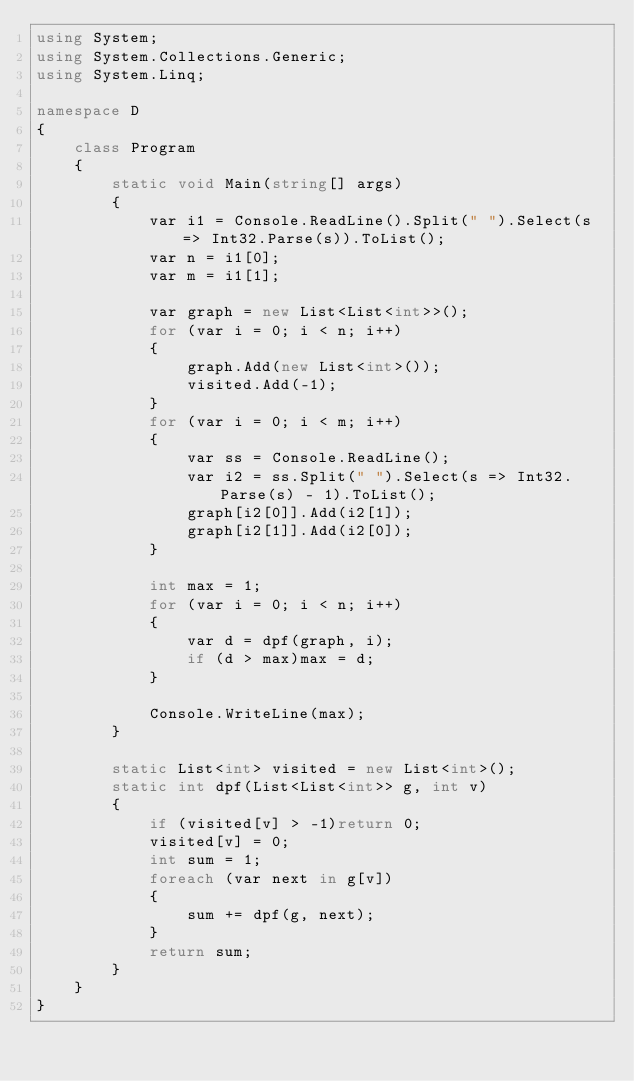<code> <loc_0><loc_0><loc_500><loc_500><_C#_>using System;
using System.Collections.Generic;
using System.Linq;

namespace D
{
    class Program
    {
        static void Main(string[] args)
        {
            var i1 = Console.ReadLine().Split(" ").Select(s => Int32.Parse(s)).ToList();
            var n = i1[0];
            var m = i1[1];

            var graph = new List<List<int>>();
            for (var i = 0; i < n; i++)
            {
                graph.Add(new List<int>());
                visited.Add(-1);
            }
            for (var i = 0; i < m; i++)
            {
                var ss = Console.ReadLine();
                var i2 = ss.Split(" ").Select(s => Int32.Parse(s) - 1).ToList();
                graph[i2[0]].Add(i2[1]);
                graph[i2[1]].Add(i2[0]);
            }

            int max = 1;
            for (var i = 0; i < n; i++)
            {
                var d = dpf(graph, i);
                if (d > max)max = d;
            }

            Console.WriteLine(max);
        }

        static List<int> visited = new List<int>();
        static int dpf(List<List<int>> g, int v)
        {
            if (visited[v] > -1)return 0;
            visited[v] = 0;
            int sum = 1;
            foreach (var next in g[v])
            {
                sum += dpf(g, next);
            }
            return sum;
        }
    }
}</code> 